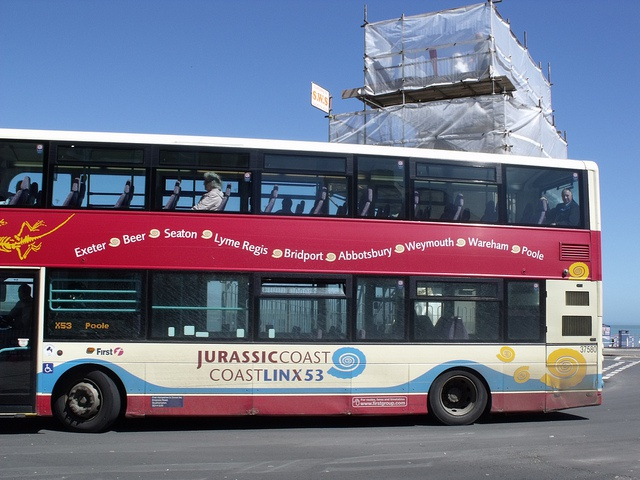Describe the objects in this image and their specific colors. I can see bus in gray, black, ivory, and brown tones, people in gray, black, and teal tones, people in gray, navy, darkblue, and darkgray tones, people in gray, darkgray, black, and lightgray tones, and people in gray, navy, lightblue, black, and blue tones in this image. 